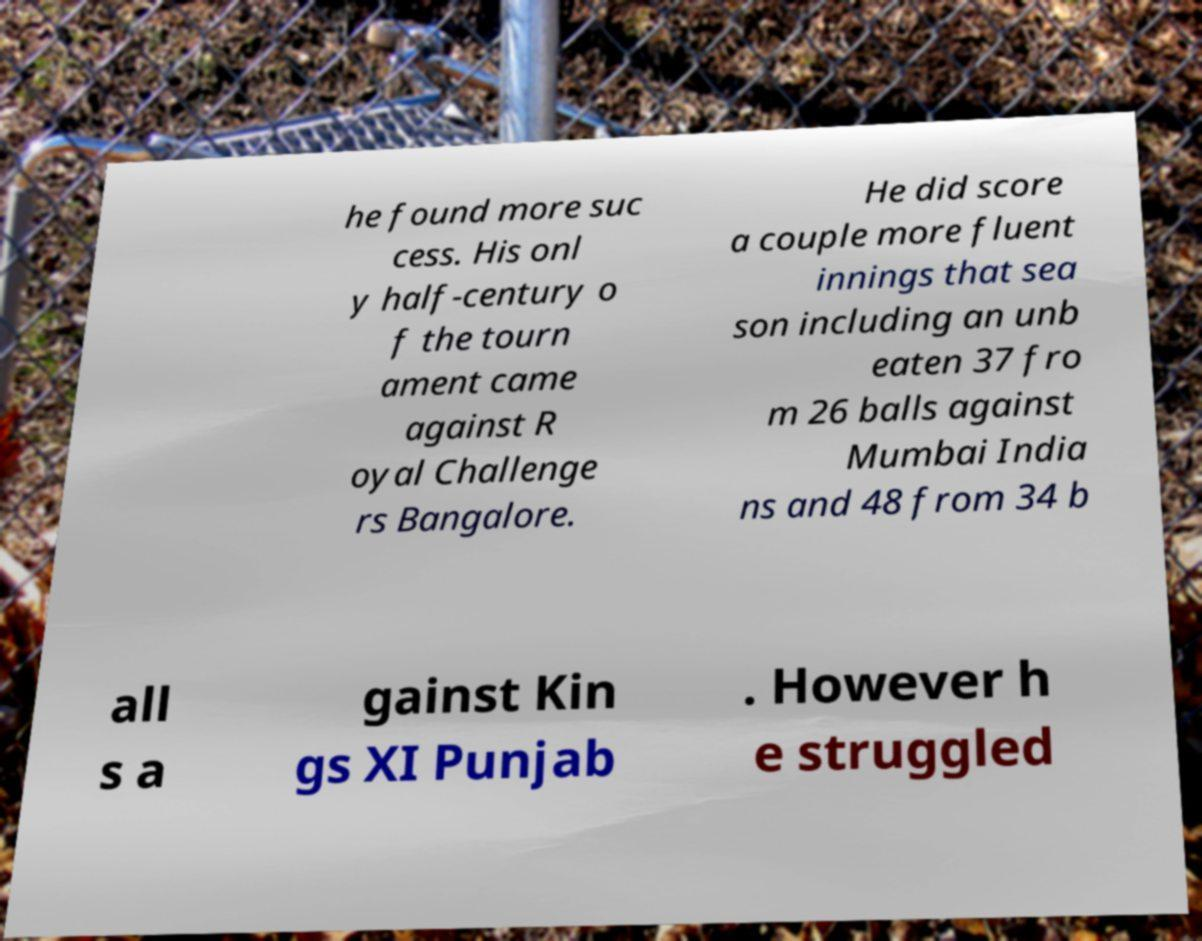For documentation purposes, I need the text within this image transcribed. Could you provide that? he found more suc cess. His onl y half-century o f the tourn ament came against R oyal Challenge rs Bangalore. He did score a couple more fluent innings that sea son including an unb eaten 37 fro m 26 balls against Mumbai India ns and 48 from 34 b all s a gainst Kin gs XI Punjab . However h e struggled 